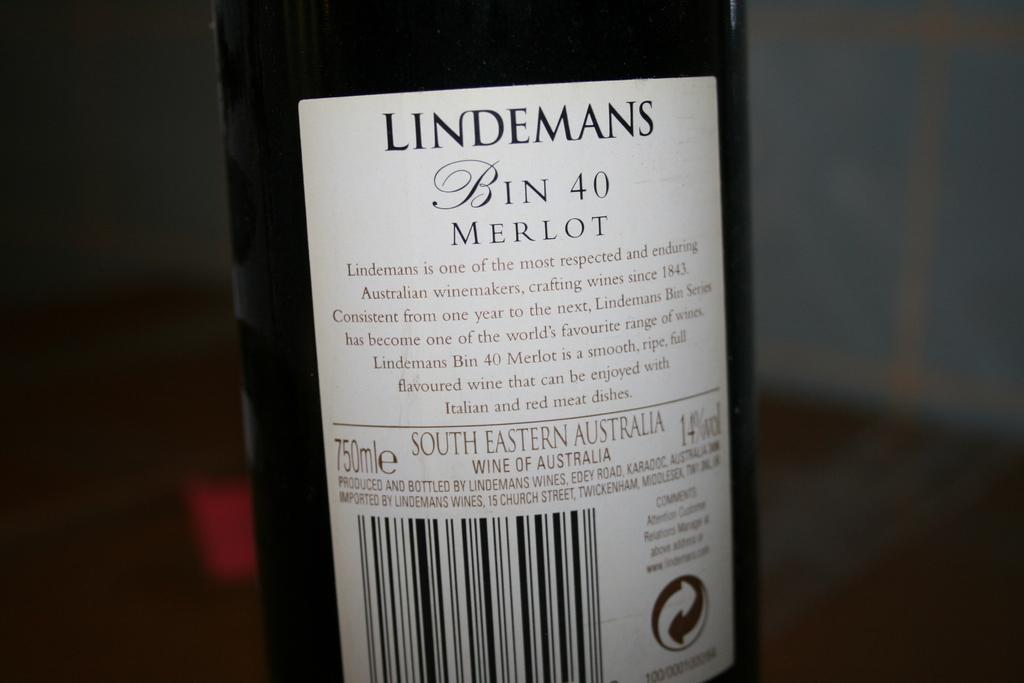<image>
Describe the image concisely. The back of a wine bottle with the brand name Lindemans. 